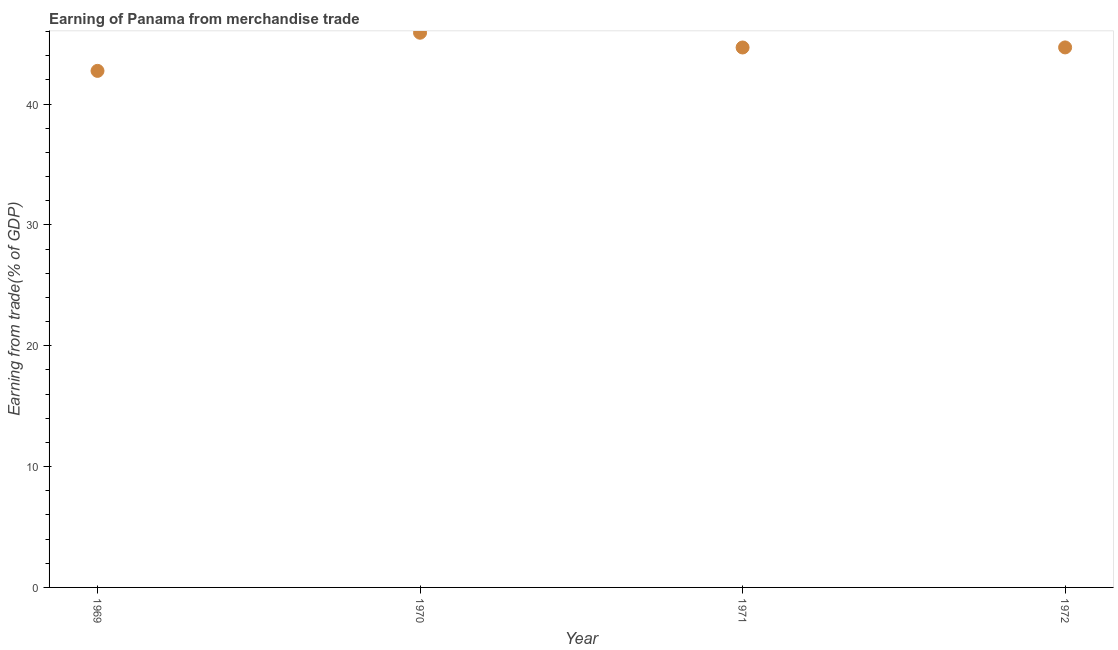What is the earning from merchandise trade in 1969?
Make the answer very short. 42.75. Across all years, what is the maximum earning from merchandise trade?
Offer a very short reply. 45.9. Across all years, what is the minimum earning from merchandise trade?
Give a very brief answer. 42.75. In which year was the earning from merchandise trade minimum?
Provide a succinct answer. 1969. What is the sum of the earning from merchandise trade?
Your answer should be very brief. 178.02. What is the difference between the earning from merchandise trade in 1969 and 1972?
Offer a terse response. -1.94. What is the average earning from merchandise trade per year?
Offer a very short reply. 44.51. What is the median earning from merchandise trade?
Your response must be concise. 44.69. What is the ratio of the earning from merchandise trade in 1969 to that in 1971?
Ensure brevity in your answer.  0.96. Is the earning from merchandise trade in 1970 less than that in 1971?
Provide a succinct answer. No. What is the difference between the highest and the second highest earning from merchandise trade?
Ensure brevity in your answer.  1.22. What is the difference between the highest and the lowest earning from merchandise trade?
Offer a very short reply. 3.16. In how many years, is the earning from merchandise trade greater than the average earning from merchandise trade taken over all years?
Keep it short and to the point. 3. Does the earning from merchandise trade monotonically increase over the years?
Your response must be concise. No. How many dotlines are there?
Your answer should be very brief. 1. How many years are there in the graph?
Provide a succinct answer. 4. What is the difference between two consecutive major ticks on the Y-axis?
Ensure brevity in your answer.  10. Are the values on the major ticks of Y-axis written in scientific E-notation?
Offer a terse response. No. What is the title of the graph?
Offer a terse response. Earning of Panama from merchandise trade. What is the label or title of the X-axis?
Your answer should be compact. Year. What is the label or title of the Y-axis?
Make the answer very short. Earning from trade(% of GDP). What is the Earning from trade(% of GDP) in 1969?
Give a very brief answer. 42.75. What is the Earning from trade(% of GDP) in 1970?
Ensure brevity in your answer.  45.9. What is the Earning from trade(% of GDP) in 1971?
Keep it short and to the point. 44.68. What is the Earning from trade(% of GDP) in 1972?
Your answer should be very brief. 44.69. What is the difference between the Earning from trade(% of GDP) in 1969 and 1970?
Offer a terse response. -3.16. What is the difference between the Earning from trade(% of GDP) in 1969 and 1971?
Your answer should be compact. -1.94. What is the difference between the Earning from trade(% of GDP) in 1969 and 1972?
Provide a succinct answer. -1.94. What is the difference between the Earning from trade(% of GDP) in 1970 and 1971?
Your response must be concise. 1.22. What is the difference between the Earning from trade(% of GDP) in 1970 and 1972?
Your answer should be very brief. 1.22. What is the difference between the Earning from trade(% of GDP) in 1971 and 1972?
Offer a terse response. -0.01. What is the ratio of the Earning from trade(% of GDP) in 1969 to that in 1970?
Give a very brief answer. 0.93. What is the ratio of the Earning from trade(% of GDP) in 1969 to that in 1971?
Your answer should be very brief. 0.96. 